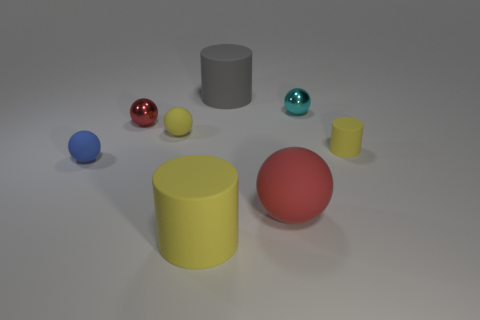The blue thing that is the same material as the big red object is what size?
Your answer should be compact. Small. What shape is the big object behind the yellow sphere?
Your answer should be very brief. Cylinder. There is a small rubber object that is to the right of the large gray matte object; is its color the same as the big rubber cylinder in front of the tiny cyan metallic object?
Offer a very short reply. Yes. What is the size of the rubber sphere that is the same color as the tiny matte cylinder?
Give a very brief answer. Small. Are any big purple metal things visible?
Your response must be concise. No. There is a red thing on the left side of the cylinder behind the tiny yellow thing behind the tiny yellow matte cylinder; what is its shape?
Keep it short and to the point. Sphere. There is a big red rubber object; how many cylinders are to the left of it?
Offer a very short reply. 2. Is the material of the large cylinder in front of the big red sphere the same as the tiny blue thing?
Offer a terse response. Yes. How many other objects are the same shape as the tiny cyan metal thing?
Provide a succinct answer. 4. How many big gray rubber things are on the left side of the yellow ball in front of the big thing behind the blue ball?
Your answer should be compact. 0. 